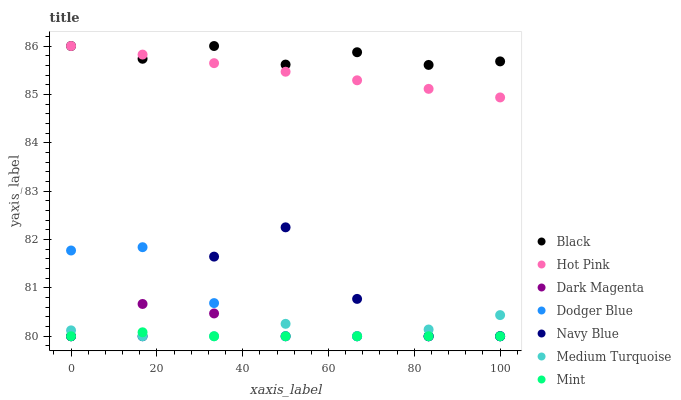Does Mint have the minimum area under the curve?
Answer yes or no. Yes. Does Black have the maximum area under the curve?
Answer yes or no. Yes. Does Navy Blue have the minimum area under the curve?
Answer yes or no. No. Does Navy Blue have the maximum area under the curve?
Answer yes or no. No. Is Hot Pink the smoothest?
Answer yes or no. Yes. Is Navy Blue the roughest?
Answer yes or no. Yes. Is Navy Blue the smoothest?
Answer yes or no. No. Is Hot Pink the roughest?
Answer yes or no. No. Does Dark Magenta have the lowest value?
Answer yes or no. Yes. Does Hot Pink have the lowest value?
Answer yes or no. No. Does Black have the highest value?
Answer yes or no. Yes. Does Navy Blue have the highest value?
Answer yes or no. No. Is Medium Turquoise less than Black?
Answer yes or no. Yes. Is Black greater than Navy Blue?
Answer yes or no. Yes. Does Medium Turquoise intersect Dark Magenta?
Answer yes or no. Yes. Is Medium Turquoise less than Dark Magenta?
Answer yes or no. No. Is Medium Turquoise greater than Dark Magenta?
Answer yes or no. No. Does Medium Turquoise intersect Black?
Answer yes or no. No. 